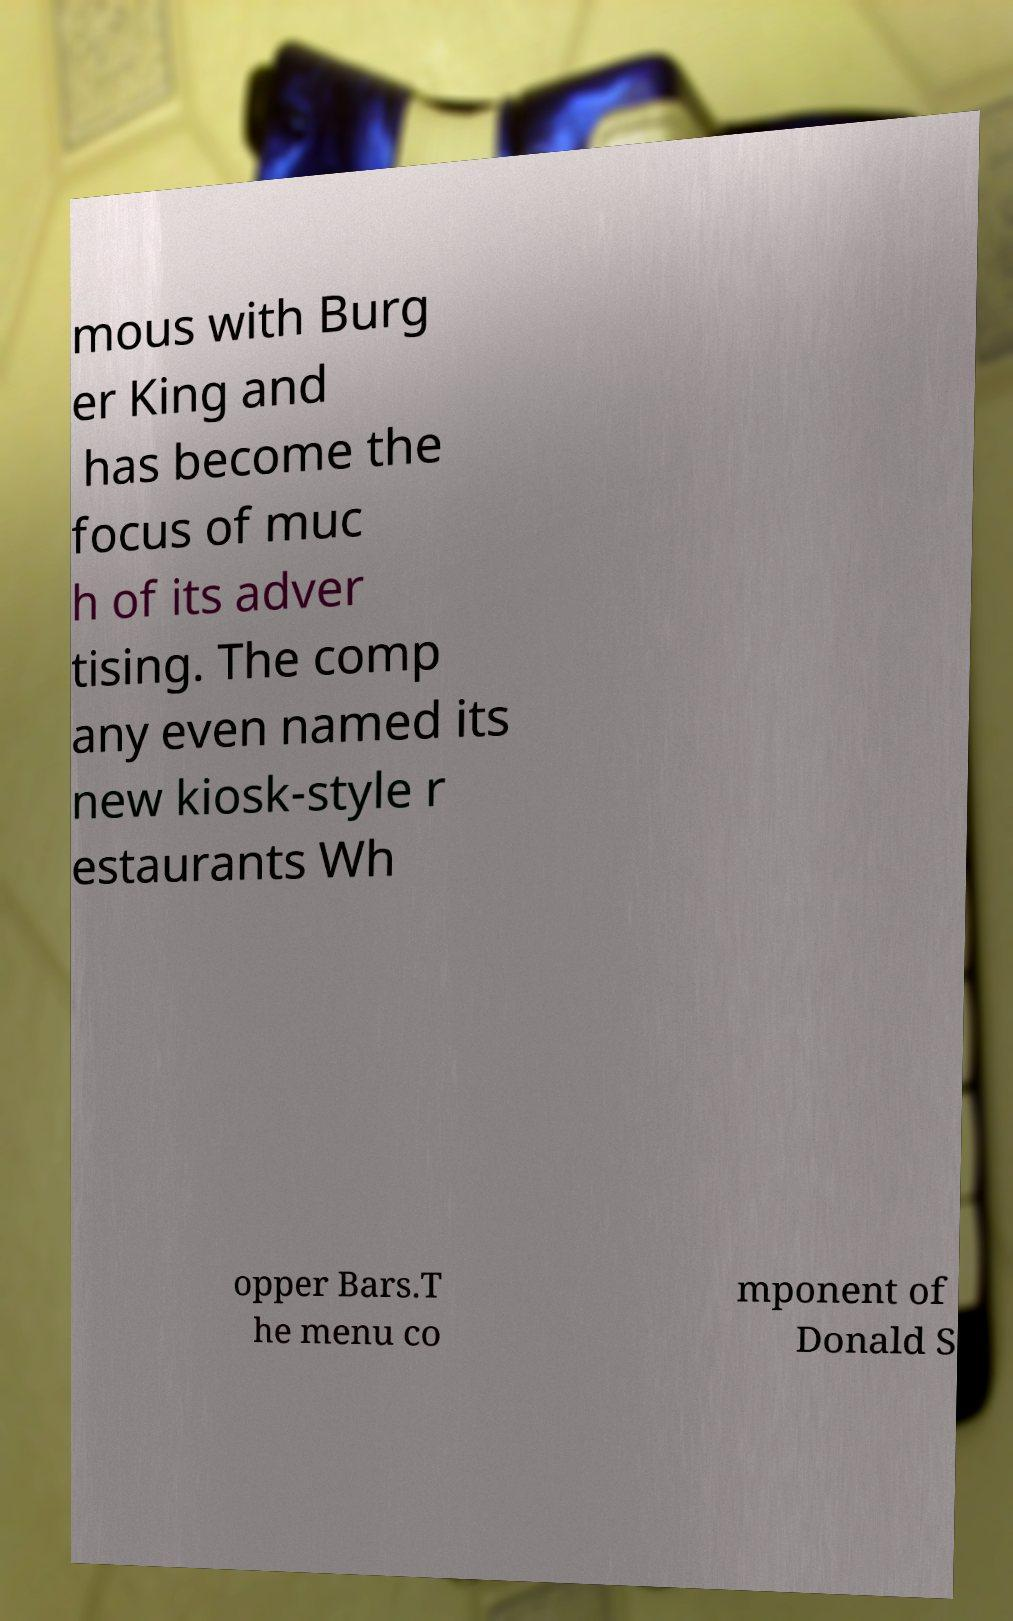Please read and relay the text visible in this image. What does it say? mous with Burg er King and has become the focus of muc h of its adver tising. The comp any even named its new kiosk-style r estaurants Wh opper Bars.T he menu co mponent of Donald S 